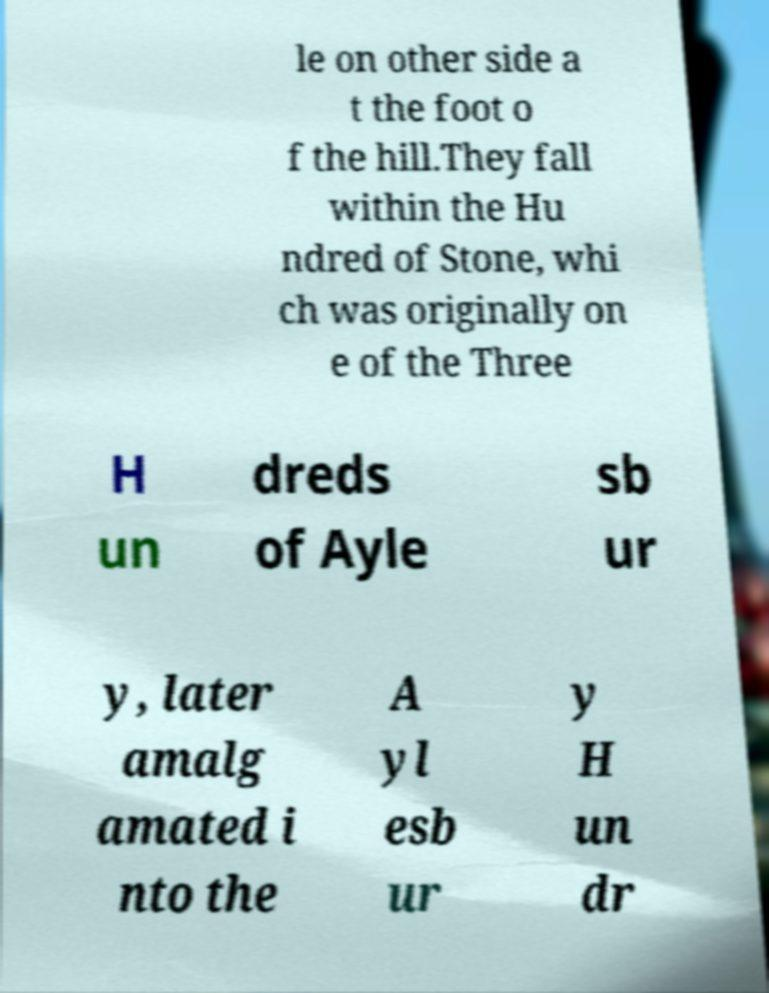Can you accurately transcribe the text from the provided image for me? le on other side a t the foot o f the hill.They fall within the Hu ndred of Stone, whi ch was originally on e of the Three H un dreds of Ayle sb ur y, later amalg amated i nto the A yl esb ur y H un dr 